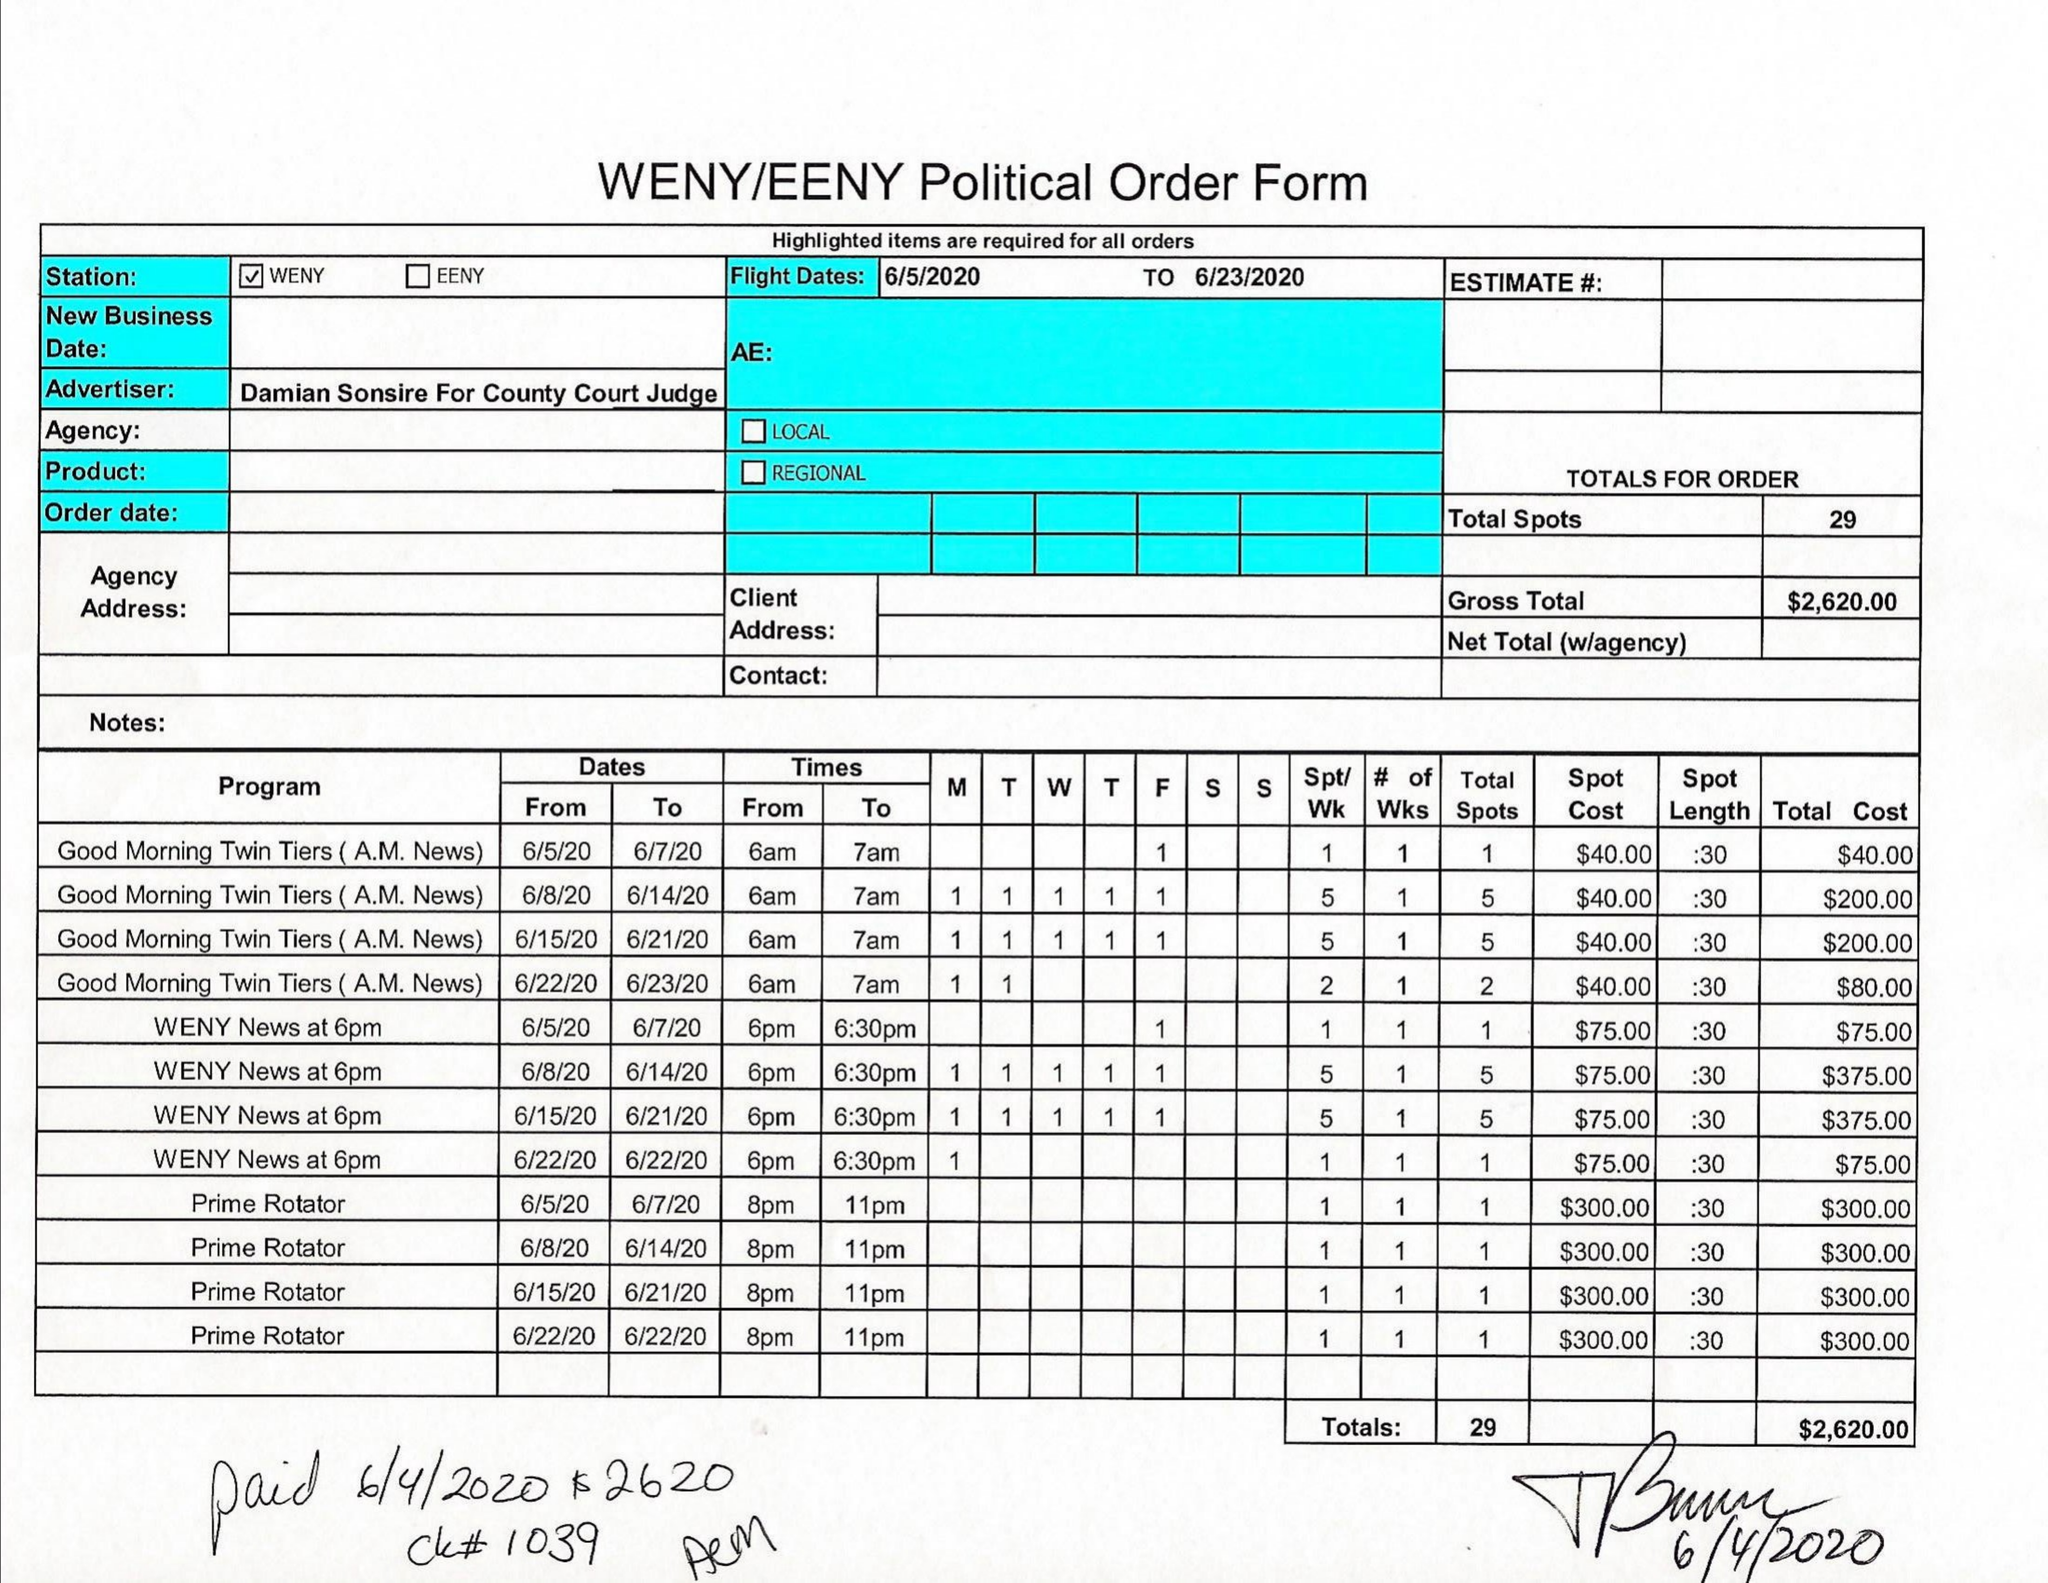What is the value for the flight_from?
Answer the question using a single word or phrase. 06/05/20 